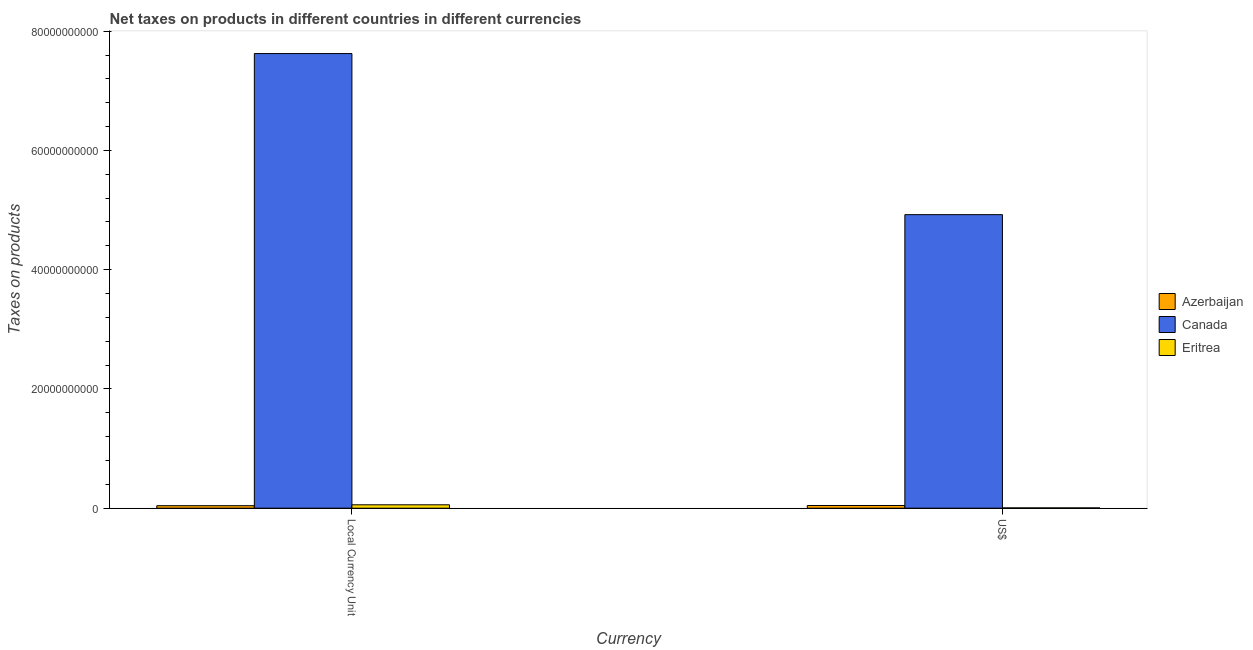How many different coloured bars are there?
Offer a very short reply. 3. How many groups of bars are there?
Provide a succinct answer. 2. Are the number of bars on each tick of the X-axis equal?
Your response must be concise. Yes. What is the label of the 1st group of bars from the left?
Make the answer very short. Local Currency Unit. What is the net taxes in us$ in Canada?
Provide a succinct answer. 4.92e+1. Across all countries, what is the maximum net taxes in constant 2005 us$?
Offer a terse response. 7.62e+1. Across all countries, what is the minimum net taxes in constant 2005 us$?
Offer a terse response. 4.18e+08. In which country was the net taxes in constant 2005 us$ maximum?
Your answer should be compact. Canada. In which country was the net taxes in constant 2005 us$ minimum?
Provide a short and direct response. Azerbaijan. What is the total net taxes in us$ in the graph?
Provide a succinct answer. 4.97e+1. What is the difference between the net taxes in constant 2005 us$ in Eritrea and that in Canada?
Give a very brief answer. -7.57e+1. What is the difference between the net taxes in constant 2005 us$ in Azerbaijan and the net taxes in us$ in Eritrea?
Your answer should be very brief. 3.68e+08. What is the average net taxes in constant 2005 us$ per country?
Your answer should be compact. 2.57e+1. What is the difference between the net taxes in us$ and net taxes in constant 2005 us$ in Eritrea?
Ensure brevity in your answer.  -5.18e+08. What is the ratio of the net taxes in constant 2005 us$ in Azerbaijan to that in Eritrea?
Offer a very short reply. 0.74. In how many countries, is the net taxes in constant 2005 us$ greater than the average net taxes in constant 2005 us$ taken over all countries?
Offer a terse response. 1. What does the 1st bar from the left in Local Currency Unit represents?
Your answer should be compact. Azerbaijan. What does the 3rd bar from the right in US$ represents?
Provide a short and direct response. Azerbaijan. Are all the bars in the graph horizontal?
Your answer should be compact. No. How many countries are there in the graph?
Your response must be concise. 3. Does the graph contain any zero values?
Provide a succinct answer. No. How many legend labels are there?
Offer a very short reply. 3. What is the title of the graph?
Your answer should be very brief. Net taxes on products in different countries in different currencies. What is the label or title of the X-axis?
Give a very brief answer. Currency. What is the label or title of the Y-axis?
Your answer should be very brief. Taxes on products. What is the Taxes on products of Azerbaijan in Local Currency Unit?
Make the answer very short. 4.18e+08. What is the Taxes on products in Canada in Local Currency Unit?
Your answer should be very brief. 7.62e+1. What is the Taxes on products in Eritrea in Local Currency Unit?
Ensure brevity in your answer.  5.68e+08. What is the Taxes on products of Azerbaijan in US$?
Your response must be concise. 4.49e+08. What is the Taxes on products in Canada in US$?
Your response must be concise. 4.92e+1. What is the Taxes on products in Eritrea in US$?
Provide a succinct answer. 5.02e+07. Across all Currency, what is the maximum Taxes on products in Azerbaijan?
Give a very brief answer. 4.49e+08. Across all Currency, what is the maximum Taxes on products in Canada?
Provide a short and direct response. 7.62e+1. Across all Currency, what is the maximum Taxes on products of Eritrea?
Provide a short and direct response. 5.68e+08. Across all Currency, what is the minimum Taxes on products of Azerbaijan?
Give a very brief answer. 4.18e+08. Across all Currency, what is the minimum Taxes on products in Canada?
Ensure brevity in your answer.  4.92e+1. Across all Currency, what is the minimum Taxes on products of Eritrea?
Provide a short and direct response. 5.02e+07. What is the total Taxes on products of Azerbaijan in the graph?
Ensure brevity in your answer.  8.68e+08. What is the total Taxes on products in Canada in the graph?
Provide a short and direct response. 1.25e+11. What is the total Taxes on products in Eritrea in the graph?
Your response must be concise. 6.18e+08. What is the difference between the Taxes on products of Azerbaijan in Local Currency Unit and that in US$?
Offer a very short reply. -3.09e+07. What is the difference between the Taxes on products of Canada in Local Currency Unit and that in US$?
Offer a terse response. 2.70e+1. What is the difference between the Taxes on products in Eritrea in Local Currency Unit and that in US$?
Give a very brief answer. 5.18e+08. What is the difference between the Taxes on products of Azerbaijan in Local Currency Unit and the Taxes on products of Canada in US$?
Ensure brevity in your answer.  -4.88e+1. What is the difference between the Taxes on products of Azerbaijan in Local Currency Unit and the Taxes on products of Eritrea in US$?
Provide a short and direct response. 3.68e+08. What is the difference between the Taxes on products of Canada in Local Currency Unit and the Taxes on products of Eritrea in US$?
Your answer should be compact. 7.62e+1. What is the average Taxes on products in Azerbaijan per Currency?
Provide a short and direct response. 4.34e+08. What is the average Taxes on products of Canada per Currency?
Your answer should be compact. 6.27e+1. What is the average Taxes on products in Eritrea per Currency?
Offer a terse response. 3.09e+08. What is the difference between the Taxes on products in Azerbaijan and Taxes on products in Canada in Local Currency Unit?
Keep it short and to the point. -7.58e+1. What is the difference between the Taxes on products in Azerbaijan and Taxes on products in Eritrea in Local Currency Unit?
Provide a succinct answer. -1.50e+08. What is the difference between the Taxes on products of Canada and Taxes on products of Eritrea in Local Currency Unit?
Make the answer very short. 7.57e+1. What is the difference between the Taxes on products of Azerbaijan and Taxes on products of Canada in US$?
Keep it short and to the point. -4.88e+1. What is the difference between the Taxes on products of Azerbaijan and Taxes on products of Eritrea in US$?
Your response must be concise. 3.99e+08. What is the difference between the Taxes on products in Canada and Taxes on products in Eritrea in US$?
Make the answer very short. 4.92e+1. What is the ratio of the Taxes on products in Azerbaijan in Local Currency Unit to that in US$?
Offer a terse response. 0.93. What is the ratio of the Taxes on products in Canada in Local Currency Unit to that in US$?
Provide a short and direct response. 1.55. What is the ratio of the Taxes on products of Eritrea in Local Currency Unit to that in US$?
Offer a terse response. 11.31. What is the difference between the highest and the second highest Taxes on products of Azerbaijan?
Your answer should be very brief. 3.09e+07. What is the difference between the highest and the second highest Taxes on products in Canada?
Offer a terse response. 2.70e+1. What is the difference between the highest and the second highest Taxes on products of Eritrea?
Provide a succinct answer. 5.18e+08. What is the difference between the highest and the lowest Taxes on products in Azerbaijan?
Provide a short and direct response. 3.09e+07. What is the difference between the highest and the lowest Taxes on products in Canada?
Your answer should be compact. 2.70e+1. What is the difference between the highest and the lowest Taxes on products in Eritrea?
Give a very brief answer. 5.18e+08. 